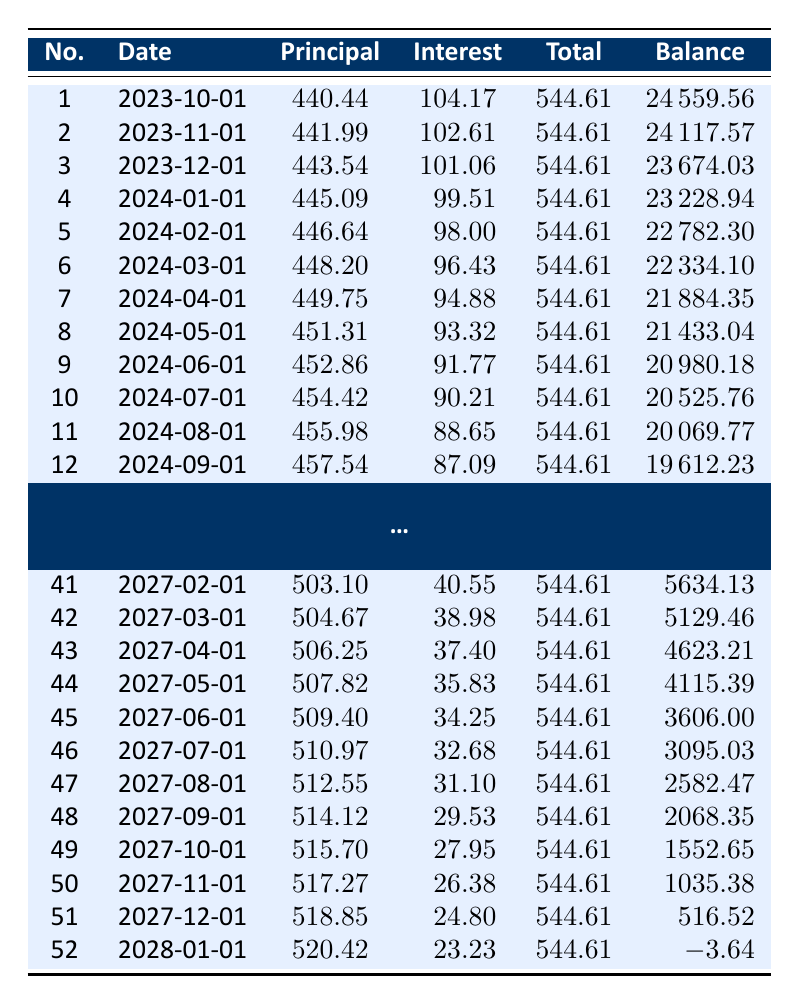What is the total principal paid by the 3rd payment? Looking at the third row of the table, the principal payment for the third payment is 443.54.
Answer: 443.54 What is the remaining balance after the 5th payment? The remaining balance after the 5th payment is shown in the 5th row, which is 22782.30.
Answer: 22782.30 On what date is the 20th payment due? From the table, the payment date for the 20th payment corresponds to the 20th row, which is 2025-05-01.
Answer: 2025-05-01 What is the average total payment from the 1st to the 5th payments? To find the average total payment, add the total payments from the first five rows: (544.61 + 544.61 + 544.61 + 544.61 + 544.61) = 2723.05. Then divide by 5: 2723.05 / 5 = 544.61.
Answer: 544.61 Is the interest payment from the 10th payment greater than 90? Referring to the 10th row, the interest payment is 90.21, which is greater than 90. Therefore, the answer is yes.
Answer: Yes After the 30th payment, what is the total principal paid up to that point? First, we need to sum the principal payments from rows 1 through 30: 440.44 + 441.99 + 443.54 + ... + 485.78. The total equals 14,057.55. Thus, the total principal paid is 14,057.55.
Answer: 14,057.55 How many payments are required to fully pay off the loan? The loan is fully paid off after 52 payments, as seen in the last row of the table.
Answer: 52 What is the difference between the total payment for the 51st payment and the total payment for the 1st payment? The total payment for the 51st payment is 544.61 (from the 51st row) and the first payment is also 544.61. The difference is 544.61 - 544.61 = 0.
Answer: 0 What are the names of the columns in the table? The columns are: No., Date, Principal, Interest, Total, and Balance, as listed at the top of the table.
Answer: No., Date, Principal, Interest, Total, Balance 